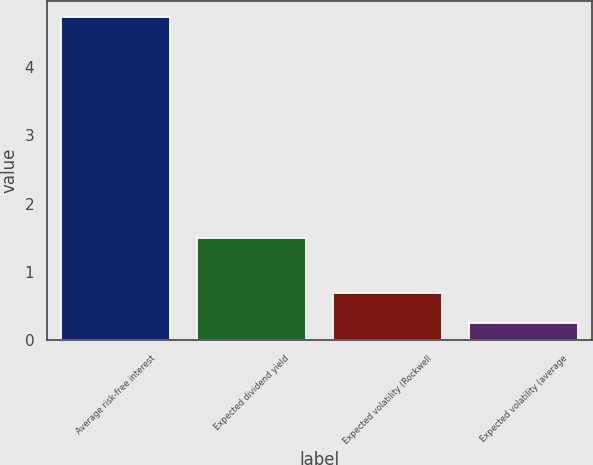Convert chart to OTSL. <chart><loc_0><loc_0><loc_500><loc_500><bar_chart><fcel>Average risk-free interest<fcel>Expected dividend yield<fcel>Expected volatility (Rockwell<fcel>Expected volatility (average<nl><fcel>4.72<fcel>1.49<fcel>0.7<fcel>0.25<nl></chart> 